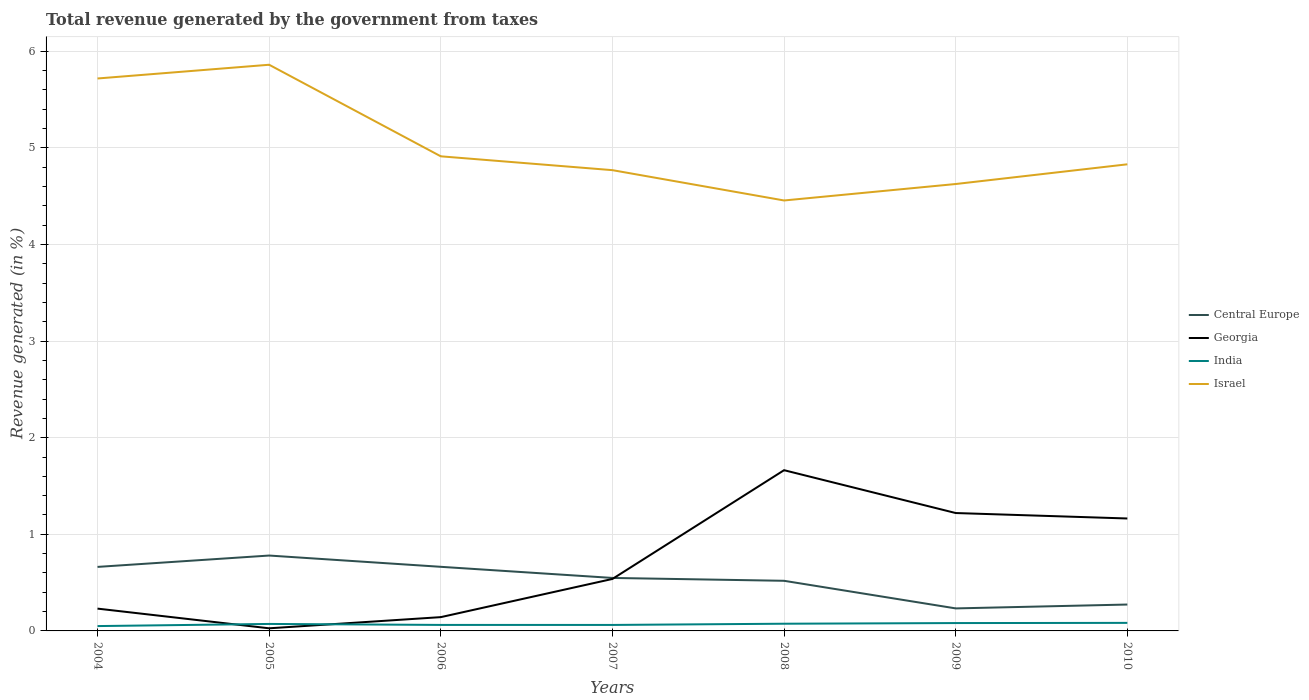Does the line corresponding to Central Europe intersect with the line corresponding to Georgia?
Provide a short and direct response. Yes. Is the number of lines equal to the number of legend labels?
Your answer should be compact. Yes. Across all years, what is the maximum total revenue generated in Central Europe?
Offer a terse response. 0.23. In which year was the total revenue generated in Georgia maximum?
Give a very brief answer. 2005. What is the total total revenue generated in India in the graph?
Keep it short and to the point. 6.086427002260919e-5. What is the difference between the highest and the second highest total revenue generated in India?
Offer a very short reply. 0.03. Is the total revenue generated in Central Europe strictly greater than the total revenue generated in Israel over the years?
Offer a terse response. Yes. How many years are there in the graph?
Keep it short and to the point. 7. Where does the legend appear in the graph?
Make the answer very short. Center right. How many legend labels are there?
Provide a short and direct response. 4. What is the title of the graph?
Provide a succinct answer. Total revenue generated by the government from taxes. What is the label or title of the Y-axis?
Your response must be concise. Revenue generated (in %). What is the Revenue generated (in %) in Central Europe in 2004?
Keep it short and to the point. 0.66. What is the Revenue generated (in %) in Georgia in 2004?
Offer a very short reply. 0.23. What is the Revenue generated (in %) of India in 2004?
Make the answer very short. 0.05. What is the Revenue generated (in %) in Israel in 2004?
Provide a short and direct response. 5.72. What is the Revenue generated (in %) in Central Europe in 2005?
Make the answer very short. 0.78. What is the Revenue generated (in %) in Georgia in 2005?
Make the answer very short. 0.03. What is the Revenue generated (in %) in India in 2005?
Provide a succinct answer. 0.07. What is the Revenue generated (in %) in Israel in 2005?
Ensure brevity in your answer.  5.86. What is the Revenue generated (in %) in Central Europe in 2006?
Your response must be concise. 0.66. What is the Revenue generated (in %) of Georgia in 2006?
Give a very brief answer. 0.14. What is the Revenue generated (in %) of India in 2006?
Offer a very short reply. 0.06. What is the Revenue generated (in %) in Israel in 2006?
Your response must be concise. 4.91. What is the Revenue generated (in %) of Central Europe in 2007?
Provide a succinct answer. 0.55. What is the Revenue generated (in %) of Georgia in 2007?
Keep it short and to the point. 0.54. What is the Revenue generated (in %) of India in 2007?
Keep it short and to the point. 0.06. What is the Revenue generated (in %) of Israel in 2007?
Your answer should be very brief. 4.77. What is the Revenue generated (in %) in Central Europe in 2008?
Keep it short and to the point. 0.52. What is the Revenue generated (in %) in Georgia in 2008?
Ensure brevity in your answer.  1.66. What is the Revenue generated (in %) of India in 2008?
Offer a very short reply. 0.07. What is the Revenue generated (in %) of Israel in 2008?
Keep it short and to the point. 4.46. What is the Revenue generated (in %) in Central Europe in 2009?
Make the answer very short. 0.23. What is the Revenue generated (in %) of Georgia in 2009?
Make the answer very short. 1.22. What is the Revenue generated (in %) in India in 2009?
Your answer should be compact. 0.08. What is the Revenue generated (in %) in Israel in 2009?
Ensure brevity in your answer.  4.63. What is the Revenue generated (in %) of Central Europe in 2010?
Give a very brief answer. 0.27. What is the Revenue generated (in %) of Georgia in 2010?
Keep it short and to the point. 1.16. What is the Revenue generated (in %) of India in 2010?
Offer a very short reply. 0.08. What is the Revenue generated (in %) of Israel in 2010?
Offer a very short reply. 4.83. Across all years, what is the maximum Revenue generated (in %) in Central Europe?
Your answer should be very brief. 0.78. Across all years, what is the maximum Revenue generated (in %) in Georgia?
Make the answer very short. 1.66. Across all years, what is the maximum Revenue generated (in %) in India?
Give a very brief answer. 0.08. Across all years, what is the maximum Revenue generated (in %) of Israel?
Provide a short and direct response. 5.86. Across all years, what is the minimum Revenue generated (in %) of Central Europe?
Ensure brevity in your answer.  0.23. Across all years, what is the minimum Revenue generated (in %) of Georgia?
Keep it short and to the point. 0.03. Across all years, what is the minimum Revenue generated (in %) of India?
Provide a short and direct response. 0.05. Across all years, what is the minimum Revenue generated (in %) in Israel?
Ensure brevity in your answer.  4.46. What is the total Revenue generated (in %) of Central Europe in the graph?
Ensure brevity in your answer.  3.68. What is the total Revenue generated (in %) of Georgia in the graph?
Keep it short and to the point. 4.99. What is the total Revenue generated (in %) in India in the graph?
Your answer should be compact. 0.49. What is the total Revenue generated (in %) in Israel in the graph?
Offer a terse response. 35.17. What is the difference between the Revenue generated (in %) of Central Europe in 2004 and that in 2005?
Offer a very short reply. -0.12. What is the difference between the Revenue generated (in %) of Georgia in 2004 and that in 2005?
Offer a very short reply. 0.2. What is the difference between the Revenue generated (in %) of India in 2004 and that in 2005?
Ensure brevity in your answer.  -0.02. What is the difference between the Revenue generated (in %) in Israel in 2004 and that in 2005?
Provide a short and direct response. -0.14. What is the difference between the Revenue generated (in %) in Central Europe in 2004 and that in 2006?
Make the answer very short. -0. What is the difference between the Revenue generated (in %) in Georgia in 2004 and that in 2006?
Your answer should be very brief. 0.09. What is the difference between the Revenue generated (in %) of India in 2004 and that in 2006?
Provide a short and direct response. -0.01. What is the difference between the Revenue generated (in %) of Israel in 2004 and that in 2006?
Offer a terse response. 0.81. What is the difference between the Revenue generated (in %) of Central Europe in 2004 and that in 2007?
Your answer should be very brief. 0.11. What is the difference between the Revenue generated (in %) in Georgia in 2004 and that in 2007?
Ensure brevity in your answer.  -0.31. What is the difference between the Revenue generated (in %) of India in 2004 and that in 2007?
Ensure brevity in your answer.  -0.01. What is the difference between the Revenue generated (in %) in Israel in 2004 and that in 2007?
Offer a terse response. 0.95. What is the difference between the Revenue generated (in %) of Central Europe in 2004 and that in 2008?
Ensure brevity in your answer.  0.14. What is the difference between the Revenue generated (in %) of Georgia in 2004 and that in 2008?
Keep it short and to the point. -1.43. What is the difference between the Revenue generated (in %) of India in 2004 and that in 2008?
Give a very brief answer. -0.02. What is the difference between the Revenue generated (in %) of Israel in 2004 and that in 2008?
Provide a succinct answer. 1.26. What is the difference between the Revenue generated (in %) of Central Europe in 2004 and that in 2009?
Your answer should be very brief. 0.43. What is the difference between the Revenue generated (in %) in Georgia in 2004 and that in 2009?
Provide a succinct answer. -0.99. What is the difference between the Revenue generated (in %) in India in 2004 and that in 2009?
Keep it short and to the point. -0.03. What is the difference between the Revenue generated (in %) in Israel in 2004 and that in 2009?
Provide a succinct answer. 1.09. What is the difference between the Revenue generated (in %) of Central Europe in 2004 and that in 2010?
Provide a short and direct response. 0.39. What is the difference between the Revenue generated (in %) of Georgia in 2004 and that in 2010?
Give a very brief answer. -0.93. What is the difference between the Revenue generated (in %) in India in 2004 and that in 2010?
Offer a terse response. -0.03. What is the difference between the Revenue generated (in %) of Israel in 2004 and that in 2010?
Your response must be concise. 0.89. What is the difference between the Revenue generated (in %) of Central Europe in 2005 and that in 2006?
Keep it short and to the point. 0.12. What is the difference between the Revenue generated (in %) of Georgia in 2005 and that in 2006?
Provide a succinct answer. -0.12. What is the difference between the Revenue generated (in %) in India in 2005 and that in 2006?
Your response must be concise. 0.01. What is the difference between the Revenue generated (in %) of Israel in 2005 and that in 2006?
Your answer should be very brief. 0.95. What is the difference between the Revenue generated (in %) in Central Europe in 2005 and that in 2007?
Provide a succinct answer. 0.23. What is the difference between the Revenue generated (in %) in Georgia in 2005 and that in 2007?
Offer a terse response. -0.51. What is the difference between the Revenue generated (in %) in India in 2005 and that in 2007?
Make the answer very short. 0.01. What is the difference between the Revenue generated (in %) in Israel in 2005 and that in 2007?
Your answer should be very brief. 1.09. What is the difference between the Revenue generated (in %) in Central Europe in 2005 and that in 2008?
Give a very brief answer. 0.26. What is the difference between the Revenue generated (in %) of Georgia in 2005 and that in 2008?
Your response must be concise. -1.64. What is the difference between the Revenue generated (in %) of India in 2005 and that in 2008?
Keep it short and to the point. -0. What is the difference between the Revenue generated (in %) in Israel in 2005 and that in 2008?
Make the answer very short. 1.4. What is the difference between the Revenue generated (in %) in Central Europe in 2005 and that in 2009?
Give a very brief answer. 0.55. What is the difference between the Revenue generated (in %) of Georgia in 2005 and that in 2009?
Give a very brief answer. -1.19. What is the difference between the Revenue generated (in %) in India in 2005 and that in 2009?
Keep it short and to the point. -0.01. What is the difference between the Revenue generated (in %) in Israel in 2005 and that in 2009?
Your answer should be compact. 1.23. What is the difference between the Revenue generated (in %) in Central Europe in 2005 and that in 2010?
Provide a succinct answer. 0.51. What is the difference between the Revenue generated (in %) in Georgia in 2005 and that in 2010?
Offer a very short reply. -1.14. What is the difference between the Revenue generated (in %) of India in 2005 and that in 2010?
Offer a terse response. -0.01. What is the difference between the Revenue generated (in %) in Israel in 2005 and that in 2010?
Your answer should be compact. 1.03. What is the difference between the Revenue generated (in %) of Central Europe in 2006 and that in 2007?
Offer a very short reply. 0.12. What is the difference between the Revenue generated (in %) of Georgia in 2006 and that in 2007?
Your answer should be compact. -0.4. What is the difference between the Revenue generated (in %) in Israel in 2006 and that in 2007?
Your answer should be compact. 0.14. What is the difference between the Revenue generated (in %) of Central Europe in 2006 and that in 2008?
Keep it short and to the point. 0.14. What is the difference between the Revenue generated (in %) of Georgia in 2006 and that in 2008?
Give a very brief answer. -1.52. What is the difference between the Revenue generated (in %) in India in 2006 and that in 2008?
Keep it short and to the point. -0.01. What is the difference between the Revenue generated (in %) in Israel in 2006 and that in 2008?
Give a very brief answer. 0.46. What is the difference between the Revenue generated (in %) in Central Europe in 2006 and that in 2009?
Your answer should be compact. 0.43. What is the difference between the Revenue generated (in %) in Georgia in 2006 and that in 2009?
Provide a short and direct response. -1.08. What is the difference between the Revenue generated (in %) in India in 2006 and that in 2009?
Offer a very short reply. -0.02. What is the difference between the Revenue generated (in %) in Israel in 2006 and that in 2009?
Offer a very short reply. 0.29. What is the difference between the Revenue generated (in %) of Central Europe in 2006 and that in 2010?
Provide a succinct answer. 0.39. What is the difference between the Revenue generated (in %) of Georgia in 2006 and that in 2010?
Your answer should be very brief. -1.02. What is the difference between the Revenue generated (in %) in India in 2006 and that in 2010?
Your answer should be very brief. -0.02. What is the difference between the Revenue generated (in %) in Israel in 2006 and that in 2010?
Keep it short and to the point. 0.08. What is the difference between the Revenue generated (in %) in Central Europe in 2007 and that in 2008?
Offer a terse response. 0.03. What is the difference between the Revenue generated (in %) in Georgia in 2007 and that in 2008?
Offer a terse response. -1.13. What is the difference between the Revenue generated (in %) in India in 2007 and that in 2008?
Your answer should be compact. -0.01. What is the difference between the Revenue generated (in %) in Israel in 2007 and that in 2008?
Make the answer very short. 0.31. What is the difference between the Revenue generated (in %) in Central Europe in 2007 and that in 2009?
Ensure brevity in your answer.  0.32. What is the difference between the Revenue generated (in %) of Georgia in 2007 and that in 2009?
Your answer should be compact. -0.68. What is the difference between the Revenue generated (in %) in India in 2007 and that in 2009?
Provide a short and direct response. -0.02. What is the difference between the Revenue generated (in %) in Israel in 2007 and that in 2009?
Provide a succinct answer. 0.14. What is the difference between the Revenue generated (in %) in Central Europe in 2007 and that in 2010?
Ensure brevity in your answer.  0.28. What is the difference between the Revenue generated (in %) in Georgia in 2007 and that in 2010?
Ensure brevity in your answer.  -0.63. What is the difference between the Revenue generated (in %) in India in 2007 and that in 2010?
Your response must be concise. -0.02. What is the difference between the Revenue generated (in %) in Israel in 2007 and that in 2010?
Your answer should be very brief. -0.06. What is the difference between the Revenue generated (in %) in Central Europe in 2008 and that in 2009?
Offer a terse response. 0.29. What is the difference between the Revenue generated (in %) of Georgia in 2008 and that in 2009?
Offer a terse response. 0.44. What is the difference between the Revenue generated (in %) in India in 2008 and that in 2009?
Provide a succinct answer. -0.01. What is the difference between the Revenue generated (in %) in Israel in 2008 and that in 2009?
Your answer should be compact. -0.17. What is the difference between the Revenue generated (in %) of Central Europe in 2008 and that in 2010?
Make the answer very short. 0.25. What is the difference between the Revenue generated (in %) in Georgia in 2008 and that in 2010?
Ensure brevity in your answer.  0.5. What is the difference between the Revenue generated (in %) of India in 2008 and that in 2010?
Your response must be concise. -0.01. What is the difference between the Revenue generated (in %) in Israel in 2008 and that in 2010?
Ensure brevity in your answer.  -0.37. What is the difference between the Revenue generated (in %) of Central Europe in 2009 and that in 2010?
Your answer should be very brief. -0.04. What is the difference between the Revenue generated (in %) of Georgia in 2009 and that in 2010?
Provide a succinct answer. 0.06. What is the difference between the Revenue generated (in %) in India in 2009 and that in 2010?
Your answer should be compact. -0. What is the difference between the Revenue generated (in %) of Israel in 2009 and that in 2010?
Your answer should be very brief. -0.2. What is the difference between the Revenue generated (in %) in Central Europe in 2004 and the Revenue generated (in %) in Georgia in 2005?
Your answer should be compact. 0.64. What is the difference between the Revenue generated (in %) of Central Europe in 2004 and the Revenue generated (in %) of India in 2005?
Give a very brief answer. 0.59. What is the difference between the Revenue generated (in %) in Central Europe in 2004 and the Revenue generated (in %) in Israel in 2005?
Provide a succinct answer. -5.2. What is the difference between the Revenue generated (in %) of Georgia in 2004 and the Revenue generated (in %) of India in 2005?
Offer a terse response. 0.16. What is the difference between the Revenue generated (in %) in Georgia in 2004 and the Revenue generated (in %) in Israel in 2005?
Keep it short and to the point. -5.63. What is the difference between the Revenue generated (in %) of India in 2004 and the Revenue generated (in %) of Israel in 2005?
Offer a very short reply. -5.81. What is the difference between the Revenue generated (in %) in Central Europe in 2004 and the Revenue generated (in %) in Georgia in 2006?
Ensure brevity in your answer.  0.52. What is the difference between the Revenue generated (in %) in Central Europe in 2004 and the Revenue generated (in %) in India in 2006?
Provide a succinct answer. 0.6. What is the difference between the Revenue generated (in %) of Central Europe in 2004 and the Revenue generated (in %) of Israel in 2006?
Keep it short and to the point. -4.25. What is the difference between the Revenue generated (in %) in Georgia in 2004 and the Revenue generated (in %) in India in 2006?
Make the answer very short. 0.17. What is the difference between the Revenue generated (in %) of Georgia in 2004 and the Revenue generated (in %) of Israel in 2006?
Your answer should be compact. -4.68. What is the difference between the Revenue generated (in %) in India in 2004 and the Revenue generated (in %) in Israel in 2006?
Provide a succinct answer. -4.86. What is the difference between the Revenue generated (in %) in Central Europe in 2004 and the Revenue generated (in %) in Georgia in 2007?
Give a very brief answer. 0.12. What is the difference between the Revenue generated (in %) of Central Europe in 2004 and the Revenue generated (in %) of India in 2007?
Keep it short and to the point. 0.6. What is the difference between the Revenue generated (in %) of Central Europe in 2004 and the Revenue generated (in %) of Israel in 2007?
Give a very brief answer. -4.11. What is the difference between the Revenue generated (in %) of Georgia in 2004 and the Revenue generated (in %) of India in 2007?
Make the answer very short. 0.17. What is the difference between the Revenue generated (in %) in Georgia in 2004 and the Revenue generated (in %) in Israel in 2007?
Keep it short and to the point. -4.54. What is the difference between the Revenue generated (in %) of India in 2004 and the Revenue generated (in %) of Israel in 2007?
Provide a short and direct response. -4.72. What is the difference between the Revenue generated (in %) in Central Europe in 2004 and the Revenue generated (in %) in Georgia in 2008?
Offer a terse response. -1. What is the difference between the Revenue generated (in %) of Central Europe in 2004 and the Revenue generated (in %) of India in 2008?
Provide a short and direct response. 0.59. What is the difference between the Revenue generated (in %) of Central Europe in 2004 and the Revenue generated (in %) of Israel in 2008?
Provide a succinct answer. -3.79. What is the difference between the Revenue generated (in %) in Georgia in 2004 and the Revenue generated (in %) in India in 2008?
Keep it short and to the point. 0.16. What is the difference between the Revenue generated (in %) in Georgia in 2004 and the Revenue generated (in %) in Israel in 2008?
Provide a succinct answer. -4.22. What is the difference between the Revenue generated (in %) of India in 2004 and the Revenue generated (in %) of Israel in 2008?
Make the answer very short. -4.41. What is the difference between the Revenue generated (in %) of Central Europe in 2004 and the Revenue generated (in %) of Georgia in 2009?
Keep it short and to the point. -0.56. What is the difference between the Revenue generated (in %) of Central Europe in 2004 and the Revenue generated (in %) of India in 2009?
Offer a terse response. 0.58. What is the difference between the Revenue generated (in %) of Central Europe in 2004 and the Revenue generated (in %) of Israel in 2009?
Your answer should be compact. -3.96. What is the difference between the Revenue generated (in %) of Georgia in 2004 and the Revenue generated (in %) of India in 2009?
Your response must be concise. 0.15. What is the difference between the Revenue generated (in %) of Georgia in 2004 and the Revenue generated (in %) of Israel in 2009?
Make the answer very short. -4.4. What is the difference between the Revenue generated (in %) of India in 2004 and the Revenue generated (in %) of Israel in 2009?
Your answer should be compact. -4.58. What is the difference between the Revenue generated (in %) of Central Europe in 2004 and the Revenue generated (in %) of Georgia in 2010?
Your response must be concise. -0.5. What is the difference between the Revenue generated (in %) in Central Europe in 2004 and the Revenue generated (in %) in India in 2010?
Provide a short and direct response. 0.58. What is the difference between the Revenue generated (in %) of Central Europe in 2004 and the Revenue generated (in %) of Israel in 2010?
Ensure brevity in your answer.  -4.17. What is the difference between the Revenue generated (in %) in Georgia in 2004 and the Revenue generated (in %) in India in 2010?
Provide a short and direct response. 0.15. What is the difference between the Revenue generated (in %) in Georgia in 2004 and the Revenue generated (in %) in Israel in 2010?
Offer a very short reply. -4.6. What is the difference between the Revenue generated (in %) of India in 2004 and the Revenue generated (in %) of Israel in 2010?
Keep it short and to the point. -4.78. What is the difference between the Revenue generated (in %) in Central Europe in 2005 and the Revenue generated (in %) in Georgia in 2006?
Your answer should be very brief. 0.64. What is the difference between the Revenue generated (in %) of Central Europe in 2005 and the Revenue generated (in %) of India in 2006?
Keep it short and to the point. 0.72. What is the difference between the Revenue generated (in %) in Central Europe in 2005 and the Revenue generated (in %) in Israel in 2006?
Give a very brief answer. -4.13. What is the difference between the Revenue generated (in %) of Georgia in 2005 and the Revenue generated (in %) of India in 2006?
Provide a succinct answer. -0.03. What is the difference between the Revenue generated (in %) of Georgia in 2005 and the Revenue generated (in %) of Israel in 2006?
Your answer should be compact. -4.89. What is the difference between the Revenue generated (in %) in India in 2005 and the Revenue generated (in %) in Israel in 2006?
Give a very brief answer. -4.84. What is the difference between the Revenue generated (in %) of Central Europe in 2005 and the Revenue generated (in %) of Georgia in 2007?
Your answer should be compact. 0.24. What is the difference between the Revenue generated (in %) in Central Europe in 2005 and the Revenue generated (in %) in India in 2007?
Make the answer very short. 0.72. What is the difference between the Revenue generated (in %) of Central Europe in 2005 and the Revenue generated (in %) of Israel in 2007?
Offer a very short reply. -3.99. What is the difference between the Revenue generated (in %) in Georgia in 2005 and the Revenue generated (in %) in India in 2007?
Give a very brief answer. -0.03. What is the difference between the Revenue generated (in %) in Georgia in 2005 and the Revenue generated (in %) in Israel in 2007?
Make the answer very short. -4.74. What is the difference between the Revenue generated (in %) in India in 2005 and the Revenue generated (in %) in Israel in 2007?
Keep it short and to the point. -4.7. What is the difference between the Revenue generated (in %) of Central Europe in 2005 and the Revenue generated (in %) of Georgia in 2008?
Your response must be concise. -0.88. What is the difference between the Revenue generated (in %) of Central Europe in 2005 and the Revenue generated (in %) of India in 2008?
Keep it short and to the point. 0.71. What is the difference between the Revenue generated (in %) of Central Europe in 2005 and the Revenue generated (in %) of Israel in 2008?
Make the answer very short. -3.68. What is the difference between the Revenue generated (in %) in Georgia in 2005 and the Revenue generated (in %) in India in 2008?
Provide a succinct answer. -0.05. What is the difference between the Revenue generated (in %) in Georgia in 2005 and the Revenue generated (in %) in Israel in 2008?
Ensure brevity in your answer.  -4.43. What is the difference between the Revenue generated (in %) in India in 2005 and the Revenue generated (in %) in Israel in 2008?
Your answer should be compact. -4.38. What is the difference between the Revenue generated (in %) in Central Europe in 2005 and the Revenue generated (in %) in Georgia in 2009?
Provide a succinct answer. -0.44. What is the difference between the Revenue generated (in %) of Central Europe in 2005 and the Revenue generated (in %) of India in 2009?
Offer a terse response. 0.7. What is the difference between the Revenue generated (in %) in Central Europe in 2005 and the Revenue generated (in %) in Israel in 2009?
Your answer should be compact. -3.85. What is the difference between the Revenue generated (in %) in Georgia in 2005 and the Revenue generated (in %) in India in 2009?
Provide a succinct answer. -0.05. What is the difference between the Revenue generated (in %) in Georgia in 2005 and the Revenue generated (in %) in Israel in 2009?
Provide a short and direct response. -4.6. What is the difference between the Revenue generated (in %) in India in 2005 and the Revenue generated (in %) in Israel in 2009?
Offer a very short reply. -4.55. What is the difference between the Revenue generated (in %) of Central Europe in 2005 and the Revenue generated (in %) of Georgia in 2010?
Provide a succinct answer. -0.38. What is the difference between the Revenue generated (in %) of Central Europe in 2005 and the Revenue generated (in %) of India in 2010?
Offer a very short reply. 0.7. What is the difference between the Revenue generated (in %) in Central Europe in 2005 and the Revenue generated (in %) in Israel in 2010?
Your answer should be very brief. -4.05. What is the difference between the Revenue generated (in %) in Georgia in 2005 and the Revenue generated (in %) in India in 2010?
Give a very brief answer. -0.06. What is the difference between the Revenue generated (in %) in Georgia in 2005 and the Revenue generated (in %) in Israel in 2010?
Your answer should be compact. -4.8. What is the difference between the Revenue generated (in %) of India in 2005 and the Revenue generated (in %) of Israel in 2010?
Give a very brief answer. -4.76. What is the difference between the Revenue generated (in %) in Central Europe in 2006 and the Revenue generated (in %) in Georgia in 2007?
Provide a short and direct response. 0.13. What is the difference between the Revenue generated (in %) in Central Europe in 2006 and the Revenue generated (in %) in India in 2007?
Make the answer very short. 0.6. What is the difference between the Revenue generated (in %) in Central Europe in 2006 and the Revenue generated (in %) in Israel in 2007?
Your answer should be very brief. -4.11. What is the difference between the Revenue generated (in %) in Georgia in 2006 and the Revenue generated (in %) in India in 2007?
Your answer should be compact. 0.08. What is the difference between the Revenue generated (in %) in Georgia in 2006 and the Revenue generated (in %) in Israel in 2007?
Offer a very short reply. -4.63. What is the difference between the Revenue generated (in %) in India in 2006 and the Revenue generated (in %) in Israel in 2007?
Provide a succinct answer. -4.71. What is the difference between the Revenue generated (in %) in Central Europe in 2006 and the Revenue generated (in %) in Georgia in 2008?
Give a very brief answer. -1. What is the difference between the Revenue generated (in %) in Central Europe in 2006 and the Revenue generated (in %) in India in 2008?
Your response must be concise. 0.59. What is the difference between the Revenue generated (in %) of Central Europe in 2006 and the Revenue generated (in %) of Israel in 2008?
Offer a terse response. -3.79. What is the difference between the Revenue generated (in %) of Georgia in 2006 and the Revenue generated (in %) of India in 2008?
Your answer should be compact. 0.07. What is the difference between the Revenue generated (in %) of Georgia in 2006 and the Revenue generated (in %) of Israel in 2008?
Offer a very short reply. -4.31. What is the difference between the Revenue generated (in %) in India in 2006 and the Revenue generated (in %) in Israel in 2008?
Your answer should be compact. -4.39. What is the difference between the Revenue generated (in %) in Central Europe in 2006 and the Revenue generated (in %) in Georgia in 2009?
Provide a succinct answer. -0.56. What is the difference between the Revenue generated (in %) of Central Europe in 2006 and the Revenue generated (in %) of India in 2009?
Provide a short and direct response. 0.58. What is the difference between the Revenue generated (in %) of Central Europe in 2006 and the Revenue generated (in %) of Israel in 2009?
Your answer should be very brief. -3.96. What is the difference between the Revenue generated (in %) in Georgia in 2006 and the Revenue generated (in %) in India in 2009?
Make the answer very short. 0.06. What is the difference between the Revenue generated (in %) of Georgia in 2006 and the Revenue generated (in %) of Israel in 2009?
Provide a succinct answer. -4.48. What is the difference between the Revenue generated (in %) in India in 2006 and the Revenue generated (in %) in Israel in 2009?
Your answer should be very brief. -4.56. What is the difference between the Revenue generated (in %) in Central Europe in 2006 and the Revenue generated (in %) in Georgia in 2010?
Provide a short and direct response. -0.5. What is the difference between the Revenue generated (in %) of Central Europe in 2006 and the Revenue generated (in %) of India in 2010?
Offer a very short reply. 0.58. What is the difference between the Revenue generated (in %) of Central Europe in 2006 and the Revenue generated (in %) of Israel in 2010?
Offer a terse response. -4.17. What is the difference between the Revenue generated (in %) in Georgia in 2006 and the Revenue generated (in %) in India in 2010?
Give a very brief answer. 0.06. What is the difference between the Revenue generated (in %) in Georgia in 2006 and the Revenue generated (in %) in Israel in 2010?
Your answer should be compact. -4.69. What is the difference between the Revenue generated (in %) of India in 2006 and the Revenue generated (in %) of Israel in 2010?
Provide a succinct answer. -4.77. What is the difference between the Revenue generated (in %) in Central Europe in 2007 and the Revenue generated (in %) in Georgia in 2008?
Provide a succinct answer. -1.12. What is the difference between the Revenue generated (in %) in Central Europe in 2007 and the Revenue generated (in %) in India in 2008?
Keep it short and to the point. 0.47. What is the difference between the Revenue generated (in %) of Central Europe in 2007 and the Revenue generated (in %) of Israel in 2008?
Keep it short and to the point. -3.91. What is the difference between the Revenue generated (in %) of Georgia in 2007 and the Revenue generated (in %) of India in 2008?
Provide a succinct answer. 0.46. What is the difference between the Revenue generated (in %) in Georgia in 2007 and the Revenue generated (in %) in Israel in 2008?
Offer a terse response. -3.92. What is the difference between the Revenue generated (in %) of India in 2007 and the Revenue generated (in %) of Israel in 2008?
Offer a very short reply. -4.39. What is the difference between the Revenue generated (in %) in Central Europe in 2007 and the Revenue generated (in %) in Georgia in 2009?
Keep it short and to the point. -0.67. What is the difference between the Revenue generated (in %) of Central Europe in 2007 and the Revenue generated (in %) of India in 2009?
Ensure brevity in your answer.  0.47. What is the difference between the Revenue generated (in %) in Central Europe in 2007 and the Revenue generated (in %) in Israel in 2009?
Make the answer very short. -4.08. What is the difference between the Revenue generated (in %) in Georgia in 2007 and the Revenue generated (in %) in India in 2009?
Give a very brief answer. 0.46. What is the difference between the Revenue generated (in %) in Georgia in 2007 and the Revenue generated (in %) in Israel in 2009?
Ensure brevity in your answer.  -4.09. What is the difference between the Revenue generated (in %) of India in 2007 and the Revenue generated (in %) of Israel in 2009?
Provide a succinct answer. -4.56. What is the difference between the Revenue generated (in %) in Central Europe in 2007 and the Revenue generated (in %) in Georgia in 2010?
Provide a succinct answer. -0.62. What is the difference between the Revenue generated (in %) in Central Europe in 2007 and the Revenue generated (in %) in India in 2010?
Provide a succinct answer. 0.47. What is the difference between the Revenue generated (in %) of Central Europe in 2007 and the Revenue generated (in %) of Israel in 2010?
Make the answer very short. -4.28. What is the difference between the Revenue generated (in %) of Georgia in 2007 and the Revenue generated (in %) of India in 2010?
Ensure brevity in your answer.  0.45. What is the difference between the Revenue generated (in %) in Georgia in 2007 and the Revenue generated (in %) in Israel in 2010?
Your answer should be compact. -4.29. What is the difference between the Revenue generated (in %) of India in 2007 and the Revenue generated (in %) of Israel in 2010?
Provide a short and direct response. -4.77. What is the difference between the Revenue generated (in %) of Central Europe in 2008 and the Revenue generated (in %) of Georgia in 2009?
Provide a short and direct response. -0.7. What is the difference between the Revenue generated (in %) in Central Europe in 2008 and the Revenue generated (in %) in India in 2009?
Keep it short and to the point. 0.44. What is the difference between the Revenue generated (in %) in Central Europe in 2008 and the Revenue generated (in %) in Israel in 2009?
Provide a succinct answer. -4.11. What is the difference between the Revenue generated (in %) in Georgia in 2008 and the Revenue generated (in %) in India in 2009?
Keep it short and to the point. 1.58. What is the difference between the Revenue generated (in %) in Georgia in 2008 and the Revenue generated (in %) in Israel in 2009?
Provide a short and direct response. -2.96. What is the difference between the Revenue generated (in %) of India in 2008 and the Revenue generated (in %) of Israel in 2009?
Your answer should be very brief. -4.55. What is the difference between the Revenue generated (in %) in Central Europe in 2008 and the Revenue generated (in %) in Georgia in 2010?
Make the answer very short. -0.65. What is the difference between the Revenue generated (in %) of Central Europe in 2008 and the Revenue generated (in %) of India in 2010?
Offer a very short reply. 0.44. What is the difference between the Revenue generated (in %) in Central Europe in 2008 and the Revenue generated (in %) in Israel in 2010?
Offer a terse response. -4.31. What is the difference between the Revenue generated (in %) of Georgia in 2008 and the Revenue generated (in %) of India in 2010?
Make the answer very short. 1.58. What is the difference between the Revenue generated (in %) in Georgia in 2008 and the Revenue generated (in %) in Israel in 2010?
Give a very brief answer. -3.17. What is the difference between the Revenue generated (in %) of India in 2008 and the Revenue generated (in %) of Israel in 2010?
Offer a very short reply. -4.76. What is the difference between the Revenue generated (in %) of Central Europe in 2009 and the Revenue generated (in %) of Georgia in 2010?
Ensure brevity in your answer.  -0.93. What is the difference between the Revenue generated (in %) of Central Europe in 2009 and the Revenue generated (in %) of India in 2010?
Make the answer very short. 0.15. What is the difference between the Revenue generated (in %) in Central Europe in 2009 and the Revenue generated (in %) in Israel in 2010?
Provide a short and direct response. -4.6. What is the difference between the Revenue generated (in %) in Georgia in 2009 and the Revenue generated (in %) in India in 2010?
Keep it short and to the point. 1.14. What is the difference between the Revenue generated (in %) of Georgia in 2009 and the Revenue generated (in %) of Israel in 2010?
Your answer should be very brief. -3.61. What is the difference between the Revenue generated (in %) in India in 2009 and the Revenue generated (in %) in Israel in 2010?
Offer a very short reply. -4.75. What is the average Revenue generated (in %) in Central Europe per year?
Give a very brief answer. 0.53. What is the average Revenue generated (in %) in Georgia per year?
Your answer should be compact. 0.71. What is the average Revenue generated (in %) of India per year?
Provide a short and direct response. 0.07. What is the average Revenue generated (in %) in Israel per year?
Provide a succinct answer. 5.02. In the year 2004, what is the difference between the Revenue generated (in %) of Central Europe and Revenue generated (in %) of Georgia?
Give a very brief answer. 0.43. In the year 2004, what is the difference between the Revenue generated (in %) of Central Europe and Revenue generated (in %) of India?
Offer a very short reply. 0.61. In the year 2004, what is the difference between the Revenue generated (in %) in Central Europe and Revenue generated (in %) in Israel?
Ensure brevity in your answer.  -5.06. In the year 2004, what is the difference between the Revenue generated (in %) of Georgia and Revenue generated (in %) of India?
Ensure brevity in your answer.  0.18. In the year 2004, what is the difference between the Revenue generated (in %) of Georgia and Revenue generated (in %) of Israel?
Provide a short and direct response. -5.49. In the year 2004, what is the difference between the Revenue generated (in %) of India and Revenue generated (in %) of Israel?
Ensure brevity in your answer.  -5.67. In the year 2005, what is the difference between the Revenue generated (in %) in Central Europe and Revenue generated (in %) in Georgia?
Your answer should be very brief. 0.75. In the year 2005, what is the difference between the Revenue generated (in %) in Central Europe and Revenue generated (in %) in India?
Give a very brief answer. 0.71. In the year 2005, what is the difference between the Revenue generated (in %) of Central Europe and Revenue generated (in %) of Israel?
Your answer should be compact. -5.08. In the year 2005, what is the difference between the Revenue generated (in %) in Georgia and Revenue generated (in %) in India?
Provide a succinct answer. -0.05. In the year 2005, what is the difference between the Revenue generated (in %) in Georgia and Revenue generated (in %) in Israel?
Keep it short and to the point. -5.83. In the year 2005, what is the difference between the Revenue generated (in %) of India and Revenue generated (in %) of Israel?
Provide a short and direct response. -5.79. In the year 2006, what is the difference between the Revenue generated (in %) of Central Europe and Revenue generated (in %) of Georgia?
Offer a terse response. 0.52. In the year 2006, what is the difference between the Revenue generated (in %) of Central Europe and Revenue generated (in %) of India?
Give a very brief answer. 0.6. In the year 2006, what is the difference between the Revenue generated (in %) in Central Europe and Revenue generated (in %) in Israel?
Provide a short and direct response. -4.25. In the year 2006, what is the difference between the Revenue generated (in %) of Georgia and Revenue generated (in %) of India?
Make the answer very short. 0.08. In the year 2006, what is the difference between the Revenue generated (in %) in Georgia and Revenue generated (in %) in Israel?
Provide a succinct answer. -4.77. In the year 2006, what is the difference between the Revenue generated (in %) of India and Revenue generated (in %) of Israel?
Your answer should be compact. -4.85. In the year 2007, what is the difference between the Revenue generated (in %) in Central Europe and Revenue generated (in %) in Georgia?
Provide a short and direct response. 0.01. In the year 2007, what is the difference between the Revenue generated (in %) in Central Europe and Revenue generated (in %) in India?
Keep it short and to the point. 0.49. In the year 2007, what is the difference between the Revenue generated (in %) of Central Europe and Revenue generated (in %) of Israel?
Ensure brevity in your answer.  -4.22. In the year 2007, what is the difference between the Revenue generated (in %) in Georgia and Revenue generated (in %) in India?
Your answer should be compact. 0.48. In the year 2007, what is the difference between the Revenue generated (in %) of Georgia and Revenue generated (in %) of Israel?
Your answer should be compact. -4.23. In the year 2007, what is the difference between the Revenue generated (in %) of India and Revenue generated (in %) of Israel?
Offer a very short reply. -4.71. In the year 2008, what is the difference between the Revenue generated (in %) in Central Europe and Revenue generated (in %) in Georgia?
Provide a succinct answer. -1.14. In the year 2008, what is the difference between the Revenue generated (in %) in Central Europe and Revenue generated (in %) in India?
Keep it short and to the point. 0.44. In the year 2008, what is the difference between the Revenue generated (in %) in Central Europe and Revenue generated (in %) in Israel?
Give a very brief answer. -3.94. In the year 2008, what is the difference between the Revenue generated (in %) of Georgia and Revenue generated (in %) of India?
Provide a short and direct response. 1.59. In the year 2008, what is the difference between the Revenue generated (in %) of Georgia and Revenue generated (in %) of Israel?
Ensure brevity in your answer.  -2.79. In the year 2008, what is the difference between the Revenue generated (in %) in India and Revenue generated (in %) in Israel?
Your response must be concise. -4.38. In the year 2009, what is the difference between the Revenue generated (in %) of Central Europe and Revenue generated (in %) of Georgia?
Provide a succinct answer. -0.99. In the year 2009, what is the difference between the Revenue generated (in %) in Central Europe and Revenue generated (in %) in India?
Give a very brief answer. 0.15. In the year 2009, what is the difference between the Revenue generated (in %) of Central Europe and Revenue generated (in %) of Israel?
Provide a succinct answer. -4.39. In the year 2009, what is the difference between the Revenue generated (in %) in Georgia and Revenue generated (in %) in India?
Provide a succinct answer. 1.14. In the year 2009, what is the difference between the Revenue generated (in %) of Georgia and Revenue generated (in %) of Israel?
Give a very brief answer. -3.41. In the year 2009, what is the difference between the Revenue generated (in %) in India and Revenue generated (in %) in Israel?
Ensure brevity in your answer.  -4.54. In the year 2010, what is the difference between the Revenue generated (in %) in Central Europe and Revenue generated (in %) in Georgia?
Offer a very short reply. -0.89. In the year 2010, what is the difference between the Revenue generated (in %) of Central Europe and Revenue generated (in %) of India?
Provide a short and direct response. 0.19. In the year 2010, what is the difference between the Revenue generated (in %) in Central Europe and Revenue generated (in %) in Israel?
Give a very brief answer. -4.56. In the year 2010, what is the difference between the Revenue generated (in %) in Georgia and Revenue generated (in %) in India?
Offer a terse response. 1.08. In the year 2010, what is the difference between the Revenue generated (in %) in Georgia and Revenue generated (in %) in Israel?
Your response must be concise. -3.67. In the year 2010, what is the difference between the Revenue generated (in %) in India and Revenue generated (in %) in Israel?
Your answer should be very brief. -4.75. What is the ratio of the Revenue generated (in %) in Central Europe in 2004 to that in 2005?
Your answer should be very brief. 0.85. What is the ratio of the Revenue generated (in %) in Georgia in 2004 to that in 2005?
Your answer should be very brief. 8.51. What is the ratio of the Revenue generated (in %) of India in 2004 to that in 2005?
Give a very brief answer. 0.69. What is the ratio of the Revenue generated (in %) in Israel in 2004 to that in 2005?
Your answer should be very brief. 0.98. What is the ratio of the Revenue generated (in %) in Georgia in 2004 to that in 2006?
Give a very brief answer. 1.62. What is the ratio of the Revenue generated (in %) of India in 2004 to that in 2006?
Your answer should be very brief. 0.81. What is the ratio of the Revenue generated (in %) of Israel in 2004 to that in 2006?
Give a very brief answer. 1.16. What is the ratio of the Revenue generated (in %) of Central Europe in 2004 to that in 2007?
Your answer should be very brief. 1.21. What is the ratio of the Revenue generated (in %) in Georgia in 2004 to that in 2007?
Give a very brief answer. 0.43. What is the ratio of the Revenue generated (in %) of India in 2004 to that in 2007?
Your answer should be compact. 0.81. What is the ratio of the Revenue generated (in %) of Israel in 2004 to that in 2007?
Your answer should be compact. 1.2. What is the ratio of the Revenue generated (in %) in Central Europe in 2004 to that in 2008?
Your response must be concise. 1.28. What is the ratio of the Revenue generated (in %) in Georgia in 2004 to that in 2008?
Ensure brevity in your answer.  0.14. What is the ratio of the Revenue generated (in %) in India in 2004 to that in 2008?
Keep it short and to the point. 0.67. What is the ratio of the Revenue generated (in %) in Israel in 2004 to that in 2008?
Offer a terse response. 1.28. What is the ratio of the Revenue generated (in %) in Central Europe in 2004 to that in 2009?
Make the answer very short. 2.84. What is the ratio of the Revenue generated (in %) of Georgia in 2004 to that in 2009?
Provide a short and direct response. 0.19. What is the ratio of the Revenue generated (in %) of India in 2004 to that in 2009?
Make the answer very short. 0.62. What is the ratio of the Revenue generated (in %) of Israel in 2004 to that in 2009?
Make the answer very short. 1.24. What is the ratio of the Revenue generated (in %) of Central Europe in 2004 to that in 2010?
Your answer should be compact. 2.43. What is the ratio of the Revenue generated (in %) of Georgia in 2004 to that in 2010?
Provide a short and direct response. 0.2. What is the ratio of the Revenue generated (in %) of India in 2004 to that in 2010?
Offer a very short reply. 0.6. What is the ratio of the Revenue generated (in %) of Israel in 2004 to that in 2010?
Offer a terse response. 1.18. What is the ratio of the Revenue generated (in %) in Central Europe in 2005 to that in 2006?
Provide a succinct answer. 1.18. What is the ratio of the Revenue generated (in %) of Georgia in 2005 to that in 2006?
Provide a succinct answer. 0.19. What is the ratio of the Revenue generated (in %) of India in 2005 to that in 2006?
Keep it short and to the point. 1.17. What is the ratio of the Revenue generated (in %) in Israel in 2005 to that in 2006?
Your answer should be compact. 1.19. What is the ratio of the Revenue generated (in %) of Central Europe in 2005 to that in 2007?
Give a very brief answer. 1.42. What is the ratio of the Revenue generated (in %) of Georgia in 2005 to that in 2007?
Make the answer very short. 0.05. What is the ratio of the Revenue generated (in %) of India in 2005 to that in 2007?
Provide a short and direct response. 1.17. What is the ratio of the Revenue generated (in %) of Israel in 2005 to that in 2007?
Offer a very short reply. 1.23. What is the ratio of the Revenue generated (in %) of Central Europe in 2005 to that in 2008?
Your answer should be very brief. 1.5. What is the ratio of the Revenue generated (in %) of Georgia in 2005 to that in 2008?
Ensure brevity in your answer.  0.02. What is the ratio of the Revenue generated (in %) in India in 2005 to that in 2008?
Your response must be concise. 0.97. What is the ratio of the Revenue generated (in %) of Israel in 2005 to that in 2008?
Offer a terse response. 1.32. What is the ratio of the Revenue generated (in %) in Central Europe in 2005 to that in 2009?
Give a very brief answer. 3.35. What is the ratio of the Revenue generated (in %) of Georgia in 2005 to that in 2009?
Provide a succinct answer. 0.02. What is the ratio of the Revenue generated (in %) of India in 2005 to that in 2009?
Keep it short and to the point. 0.89. What is the ratio of the Revenue generated (in %) in Israel in 2005 to that in 2009?
Your response must be concise. 1.27. What is the ratio of the Revenue generated (in %) of Central Europe in 2005 to that in 2010?
Your answer should be very brief. 2.86. What is the ratio of the Revenue generated (in %) in Georgia in 2005 to that in 2010?
Ensure brevity in your answer.  0.02. What is the ratio of the Revenue generated (in %) of India in 2005 to that in 2010?
Offer a very short reply. 0.87. What is the ratio of the Revenue generated (in %) in Israel in 2005 to that in 2010?
Offer a terse response. 1.21. What is the ratio of the Revenue generated (in %) of Central Europe in 2006 to that in 2007?
Your response must be concise. 1.21. What is the ratio of the Revenue generated (in %) of Georgia in 2006 to that in 2007?
Your answer should be compact. 0.27. What is the ratio of the Revenue generated (in %) of Israel in 2006 to that in 2007?
Your answer should be compact. 1.03. What is the ratio of the Revenue generated (in %) in Central Europe in 2006 to that in 2008?
Make the answer very short. 1.28. What is the ratio of the Revenue generated (in %) of Georgia in 2006 to that in 2008?
Offer a terse response. 0.09. What is the ratio of the Revenue generated (in %) in India in 2006 to that in 2008?
Keep it short and to the point. 0.83. What is the ratio of the Revenue generated (in %) in Israel in 2006 to that in 2008?
Your answer should be compact. 1.1. What is the ratio of the Revenue generated (in %) of Central Europe in 2006 to that in 2009?
Provide a succinct answer. 2.85. What is the ratio of the Revenue generated (in %) of Georgia in 2006 to that in 2009?
Offer a very short reply. 0.12. What is the ratio of the Revenue generated (in %) in India in 2006 to that in 2009?
Make the answer very short. 0.76. What is the ratio of the Revenue generated (in %) of Israel in 2006 to that in 2009?
Provide a short and direct response. 1.06. What is the ratio of the Revenue generated (in %) of Central Europe in 2006 to that in 2010?
Your answer should be compact. 2.43. What is the ratio of the Revenue generated (in %) in Georgia in 2006 to that in 2010?
Ensure brevity in your answer.  0.12. What is the ratio of the Revenue generated (in %) in India in 2006 to that in 2010?
Keep it short and to the point. 0.74. What is the ratio of the Revenue generated (in %) of Israel in 2006 to that in 2010?
Your answer should be compact. 1.02. What is the ratio of the Revenue generated (in %) of Central Europe in 2007 to that in 2008?
Ensure brevity in your answer.  1.06. What is the ratio of the Revenue generated (in %) of Georgia in 2007 to that in 2008?
Provide a succinct answer. 0.32. What is the ratio of the Revenue generated (in %) of India in 2007 to that in 2008?
Give a very brief answer. 0.83. What is the ratio of the Revenue generated (in %) of Israel in 2007 to that in 2008?
Offer a very short reply. 1.07. What is the ratio of the Revenue generated (in %) in Central Europe in 2007 to that in 2009?
Ensure brevity in your answer.  2.35. What is the ratio of the Revenue generated (in %) in Georgia in 2007 to that in 2009?
Provide a succinct answer. 0.44. What is the ratio of the Revenue generated (in %) of India in 2007 to that in 2009?
Provide a succinct answer. 0.76. What is the ratio of the Revenue generated (in %) of Israel in 2007 to that in 2009?
Your answer should be very brief. 1.03. What is the ratio of the Revenue generated (in %) in Central Europe in 2007 to that in 2010?
Keep it short and to the point. 2.01. What is the ratio of the Revenue generated (in %) of Georgia in 2007 to that in 2010?
Give a very brief answer. 0.46. What is the ratio of the Revenue generated (in %) in India in 2007 to that in 2010?
Provide a succinct answer. 0.74. What is the ratio of the Revenue generated (in %) in Israel in 2007 to that in 2010?
Ensure brevity in your answer.  0.99. What is the ratio of the Revenue generated (in %) of Central Europe in 2008 to that in 2009?
Provide a short and direct response. 2.23. What is the ratio of the Revenue generated (in %) of Georgia in 2008 to that in 2009?
Offer a terse response. 1.36. What is the ratio of the Revenue generated (in %) in India in 2008 to that in 2009?
Keep it short and to the point. 0.92. What is the ratio of the Revenue generated (in %) in Israel in 2008 to that in 2009?
Give a very brief answer. 0.96. What is the ratio of the Revenue generated (in %) in Central Europe in 2008 to that in 2010?
Your response must be concise. 1.9. What is the ratio of the Revenue generated (in %) in Georgia in 2008 to that in 2010?
Offer a very short reply. 1.43. What is the ratio of the Revenue generated (in %) in India in 2008 to that in 2010?
Make the answer very short. 0.9. What is the ratio of the Revenue generated (in %) of Israel in 2008 to that in 2010?
Keep it short and to the point. 0.92. What is the ratio of the Revenue generated (in %) of Central Europe in 2009 to that in 2010?
Provide a short and direct response. 0.85. What is the ratio of the Revenue generated (in %) in Georgia in 2009 to that in 2010?
Your answer should be compact. 1.05. What is the ratio of the Revenue generated (in %) of India in 2009 to that in 2010?
Make the answer very short. 0.98. What is the ratio of the Revenue generated (in %) in Israel in 2009 to that in 2010?
Provide a short and direct response. 0.96. What is the difference between the highest and the second highest Revenue generated (in %) of Central Europe?
Keep it short and to the point. 0.12. What is the difference between the highest and the second highest Revenue generated (in %) in Georgia?
Give a very brief answer. 0.44. What is the difference between the highest and the second highest Revenue generated (in %) of India?
Give a very brief answer. 0. What is the difference between the highest and the second highest Revenue generated (in %) of Israel?
Ensure brevity in your answer.  0.14. What is the difference between the highest and the lowest Revenue generated (in %) of Central Europe?
Provide a short and direct response. 0.55. What is the difference between the highest and the lowest Revenue generated (in %) in Georgia?
Your answer should be compact. 1.64. What is the difference between the highest and the lowest Revenue generated (in %) in Israel?
Make the answer very short. 1.4. 